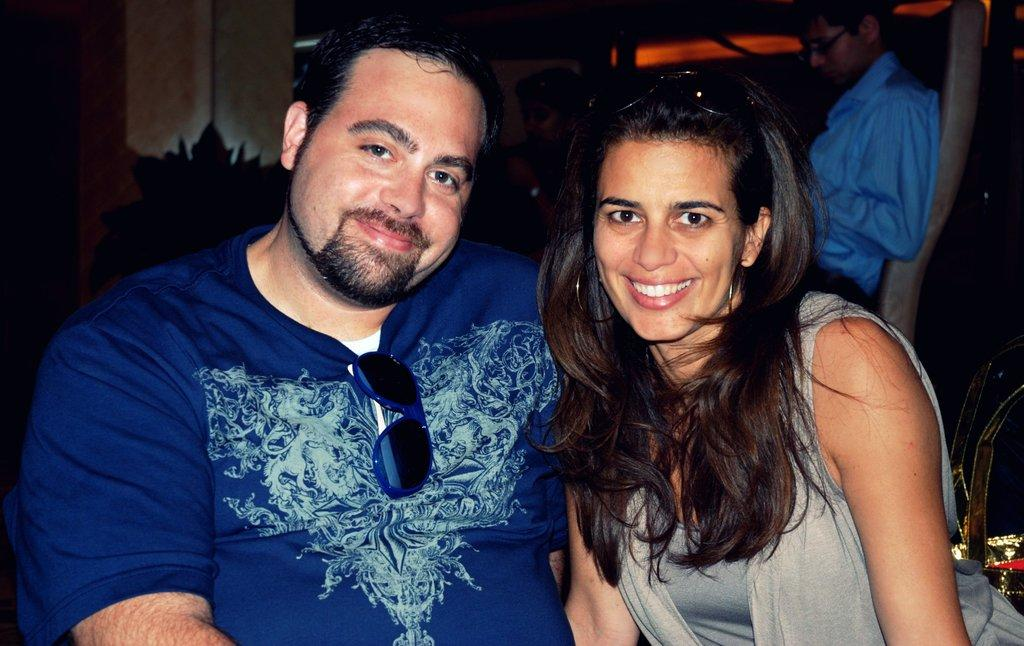How many people are sitting in the image? There are two persons sitting in the image. What is the facial expression of the people in the image? The two persons are smiling. What type of eyewear do the woman and man have? The woman and man have goggles. Can you describe the background of the image? There are people in the background of the image. How would you describe the overall lighting in the image? The rest of the image is dark. What type of volleyball is being played in the image? There is no volleyball present in the image. How does the dust affect the visibility of the people in the image? There is no mention of dust in the image, so it cannot affect the visibility of the people. 